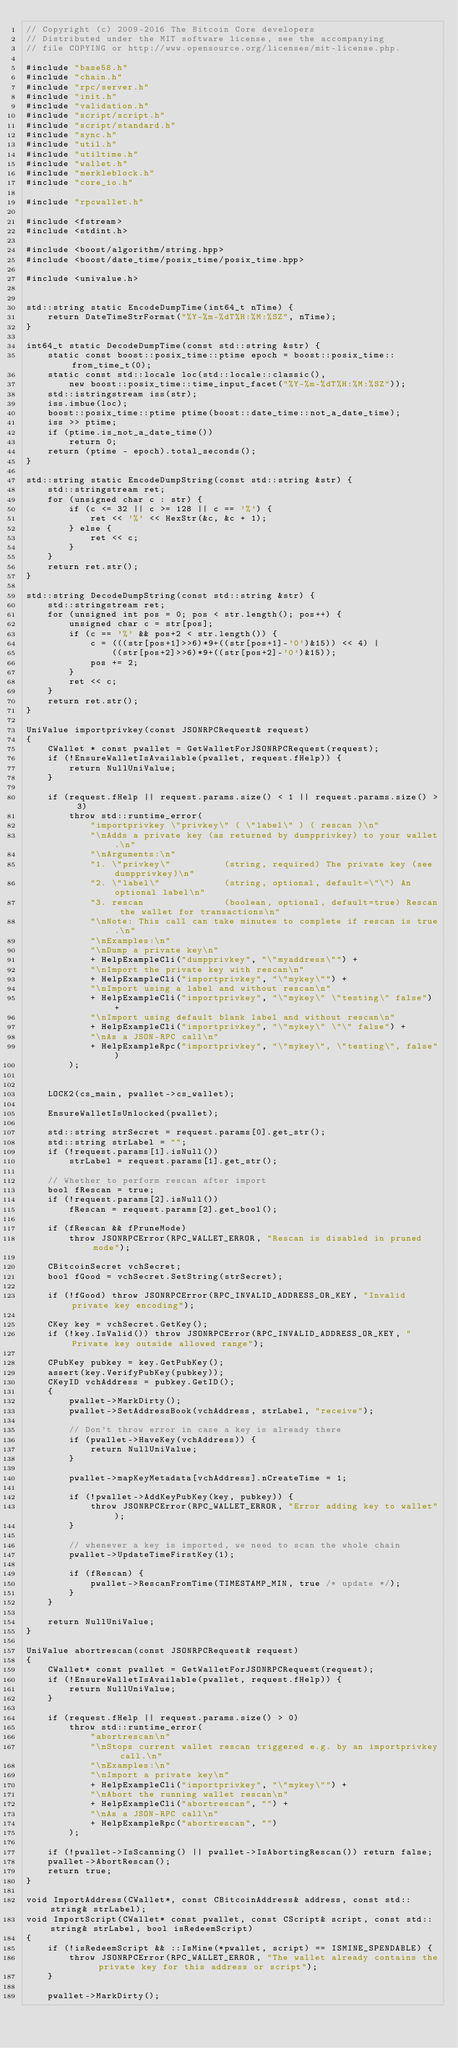Convert code to text. <code><loc_0><loc_0><loc_500><loc_500><_C++_>// Copyright (c) 2009-2016 The Bitcoin Core developers
// Distributed under the MIT software license, see the accompanying
// file COPYING or http://www.opensource.org/licenses/mit-license.php.

#include "base58.h"
#include "chain.h"
#include "rpc/server.h"
#include "init.h"
#include "validation.h"
#include "script/script.h"
#include "script/standard.h"
#include "sync.h"
#include "util.h"
#include "utiltime.h"
#include "wallet.h"
#include "merkleblock.h"
#include "core_io.h"

#include "rpcwallet.h"

#include <fstream>
#include <stdint.h>

#include <boost/algorithm/string.hpp>
#include <boost/date_time/posix_time/posix_time.hpp>

#include <univalue.h>


std::string static EncodeDumpTime(int64_t nTime) {
    return DateTimeStrFormat("%Y-%m-%dT%H:%M:%SZ", nTime);
}

int64_t static DecodeDumpTime(const std::string &str) {
    static const boost::posix_time::ptime epoch = boost::posix_time::from_time_t(0);
    static const std::locale loc(std::locale::classic(),
        new boost::posix_time::time_input_facet("%Y-%m-%dT%H:%M:%SZ"));
    std::istringstream iss(str);
    iss.imbue(loc);
    boost::posix_time::ptime ptime(boost::date_time::not_a_date_time);
    iss >> ptime;
    if (ptime.is_not_a_date_time())
        return 0;
    return (ptime - epoch).total_seconds();
}

std::string static EncodeDumpString(const std::string &str) {
    std::stringstream ret;
    for (unsigned char c : str) {
        if (c <= 32 || c >= 128 || c == '%') {
            ret << '%' << HexStr(&c, &c + 1);
        } else {
            ret << c;
        }
    }
    return ret.str();
}

std::string DecodeDumpString(const std::string &str) {
    std::stringstream ret;
    for (unsigned int pos = 0; pos < str.length(); pos++) {
        unsigned char c = str[pos];
        if (c == '%' && pos+2 < str.length()) {
            c = (((str[pos+1]>>6)*9+((str[pos+1]-'0')&15)) << 4) | 
                ((str[pos+2]>>6)*9+((str[pos+2]-'0')&15));
            pos += 2;
        }
        ret << c;
    }
    return ret.str();
}

UniValue importprivkey(const JSONRPCRequest& request)
{
    CWallet * const pwallet = GetWalletForJSONRPCRequest(request);
    if (!EnsureWalletIsAvailable(pwallet, request.fHelp)) {
        return NullUniValue;
    }

    if (request.fHelp || request.params.size() < 1 || request.params.size() > 3)
        throw std::runtime_error(
            "importprivkey \"privkey\" ( \"label\" ) ( rescan )\n"
            "\nAdds a private key (as returned by dumpprivkey) to your wallet.\n"
            "\nArguments:\n"
            "1. \"privkey\"          (string, required) The private key (see dumpprivkey)\n"
            "2. \"label\"            (string, optional, default=\"\") An optional label\n"
            "3. rescan               (boolean, optional, default=true) Rescan the wallet for transactions\n"
            "\nNote: This call can take minutes to complete if rescan is true.\n"
            "\nExamples:\n"
            "\nDump a private key\n"
            + HelpExampleCli("dumpprivkey", "\"myaddress\"") +
            "\nImport the private key with rescan\n"
            + HelpExampleCli("importprivkey", "\"mykey\"") +
            "\nImport using a label and without rescan\n"
            + HelpExampleCli("importprivkey", "\"mykey\" \"testing\" false") +
            "\nImport using default blank label and without rescan\n"
            + HelpExampleCli("importprivkey", "\"mykey\" \"\" false") +
            "\nAs a JSON-RPC call\n"
            + HelpExampleRpc("importprivkey", "\"mykey\", \"testing\", false")
        );


    LOCK2(cs_main, pwallet->cs_wallet);

    EnsureWalletIsUnlocked(pwallet);

    std::string strSecret = request.params[0].get_str();
    std::string strLabel = "";
    if (!request.params[1].isNull())
        strLabel = request.params[1].get_str();

    // Whether to perform rescan after import
    bool fRescan = true;
    if (!request.params[2].isNull())
        fRescan = request.params[2].get_bool();

    if (fRescan && fPruneMode)
        throw JSONRPCError(RPC_WALLET_ERROR, "Rescan is disabled in pruned mode");

    CBitcoinSecret vchSecret;
    bool fGood = vchSecret.SetString(strSecret);

    if (!fGood) throw JSONRPCError(RPC_INVALID_ADDRESS_OR_KEY, "Invalid private key encoding");

    CKey key = vchSecret.GetKey();
    if (!key.IsValid()) throw JSONRPCError(RPC_INVALID_ADDRESS_OR_KEY, "Private key outside allowed range");

    CPubKey pubkey = key.GetPubKey();
    assert(key.VerifyPubKey(pubkey));
    CKeyID vchAddress = pubkey.GetID();
    {
        pwallet->MarkDirty();
        pwallet->SetAddressBook(vchAddress, strLabel, "receive");

        // Don't throw error in case a key is already there
        if (pwallet->HaveKey(vchAddress)) {
            return NullUniValue;
        }

        pwallet->mapKeyMetadata[vchAddress].nCreateTime = 1;

        if (!pwallet->AddKeyPubKey(key, pubkey)) {
            throw JSONRPCError(RPC_WALLET_ERROR, "Error adding key to wallet");
        }

        // whenever a key is imported, we need to scan the whole chain
        pwallet->UpdateTimeFirstKey(1);

        if (fRescan) {
            pwallet->RescanFromTime(TIMESTAMP_MIN, true /* update */);
        }
    }

    return NullUniValue;
}

UniValue abortrescan(const JSONRPCRequest& request)
{
    CWallet* const pwallet = GetWalletForJSONRPCRequest(request);
    if (!EnsureWalletIsAvailable(pwallet, request.fHelp)) {
        return NullUniValue;
    }

    if (request.fHelp || request.params.size() > 0)
        throw std::runtime_error(
            "abortrescan\n"
            "\nStops current wallet rescan triggered e.g. by an importprivkey call.\n"
            "\nExamples:\n"
            "\nImport a private key\n"
            + HelpExampleCli("importprivkey", "\"mykey\"") +
            "\nAbort the running wallet rescan\n"
            + HelpExampleCli("abortrescan", "") +
            "\nAs a JSON-RPC call\n"
            + HelpExampleRpc("abortrescan", "")
        );

    if (!pwallet->IsScanning() || pwallet->IsAbortingRescan()) return false;
    pwallet->AbortRescan();
    return true;
}

void ImportAddress(CWallet*, const CBitcoinAddress& address, const std::string& strLabel);
void ImportScript(CWallet* const pwallet, const CScript& script, const std::string& strLabel, bool isRedeemScript)
{
    if (!isRedeemScript && ::IsMine(*pwallet, script) == ISMINE_SPENDABLE) {
        throw JSONRPCError(RPC_WALLET_ERROR, "The wallet already contains the private key for this address or script");
    }

    pwallet->MarkDirty();
</code> 